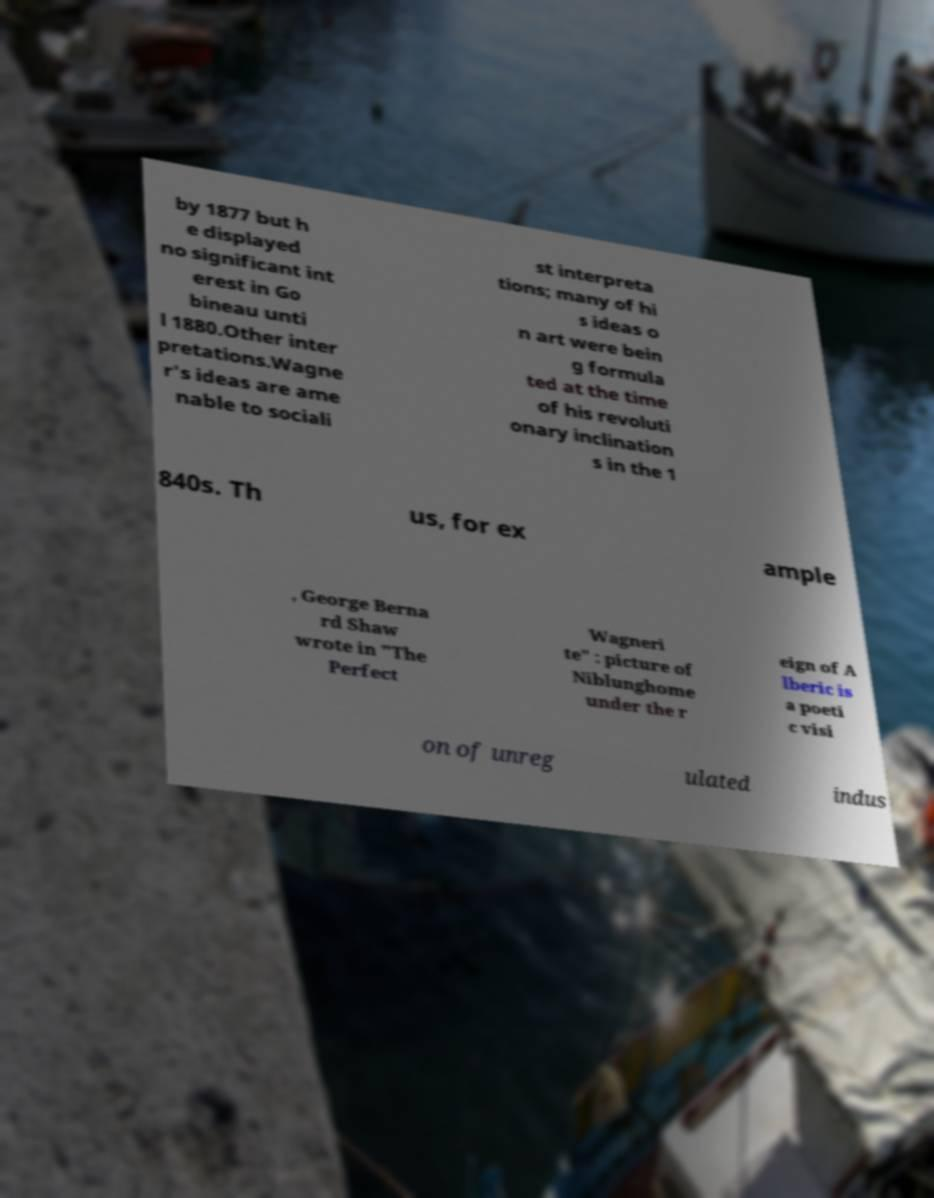What messages or text are displayed in this image? I need them in a readable, typed format. by 1877 but h e displayed no significant int erest in Go bineau unti l 1880.Other inter pretations.Wagne r's ideas are ame nable to sociali st interpreta tions; many of hi s ideas o n art were bein g formula ted at the time of his revoluti onary inclination s in the 1 840s. Th us, for ex ample , George Berna rd Shaw wrote in "The Perfect Wagneri te" : picture of Niblunghome under the r eign of A lberic is a poeti c visi on of unreg ulated indus 